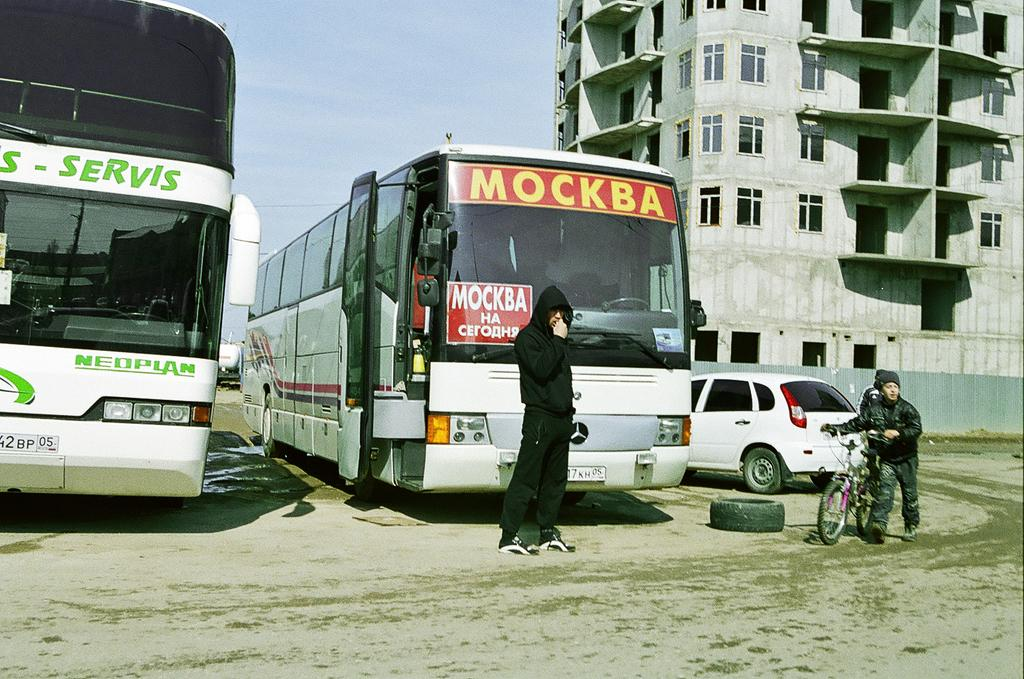<image>
Create a compact narrative representing the image presented. Bus parked with a word that says MOCKBA on the top. 